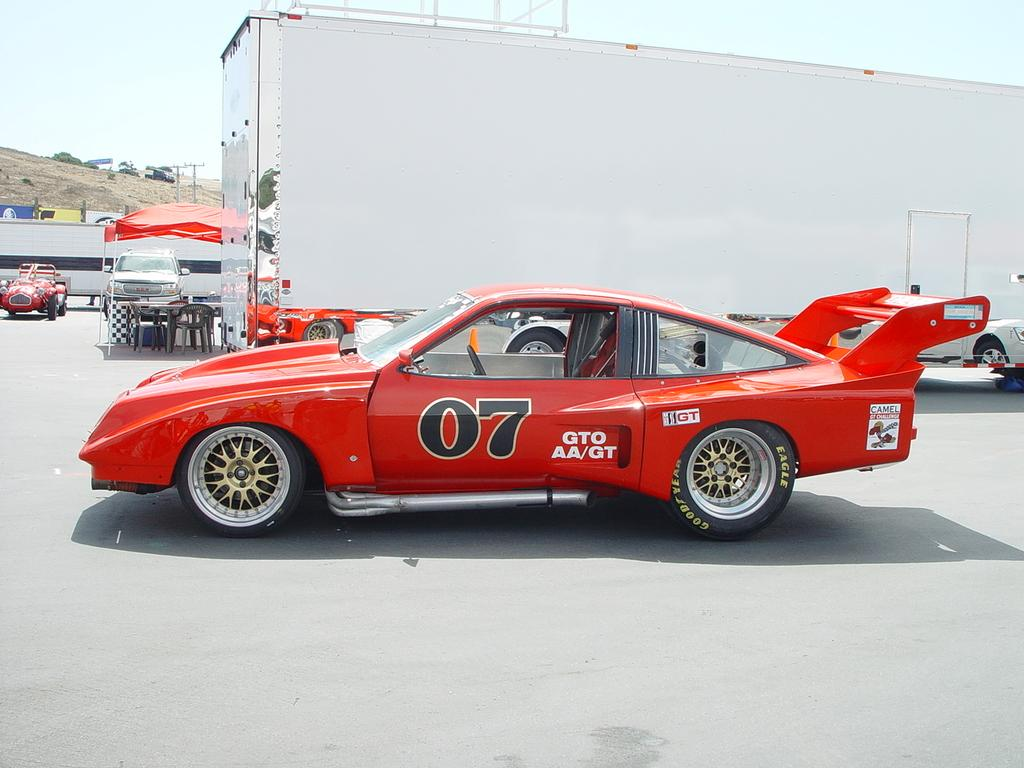What type of vehicles can be seen on the path in the image? There are cars on the path in the image. What object is present for storage or transportation purposes? There is a container in the image. What type of temporary shelter is visible in the image? There is a tent with poles in the image. What type of furniture is present for seating purposes? There are chairs in the image. What type of surface is present for placing objects or serving food? There is a table in the image. What type of natural scenery can be seen in the background of the image? There are trees in the background of the image. What part of the natural environment is visible in the background of the image? The sky is visible in the background of the image. How many fingers are visible on the person operating the car in the image? There is no person operating the car in the image, and therefore no fingers are visible. What type of plant is growing near the tent in the image? There is no mention of a plant growing near the tent in the image. 